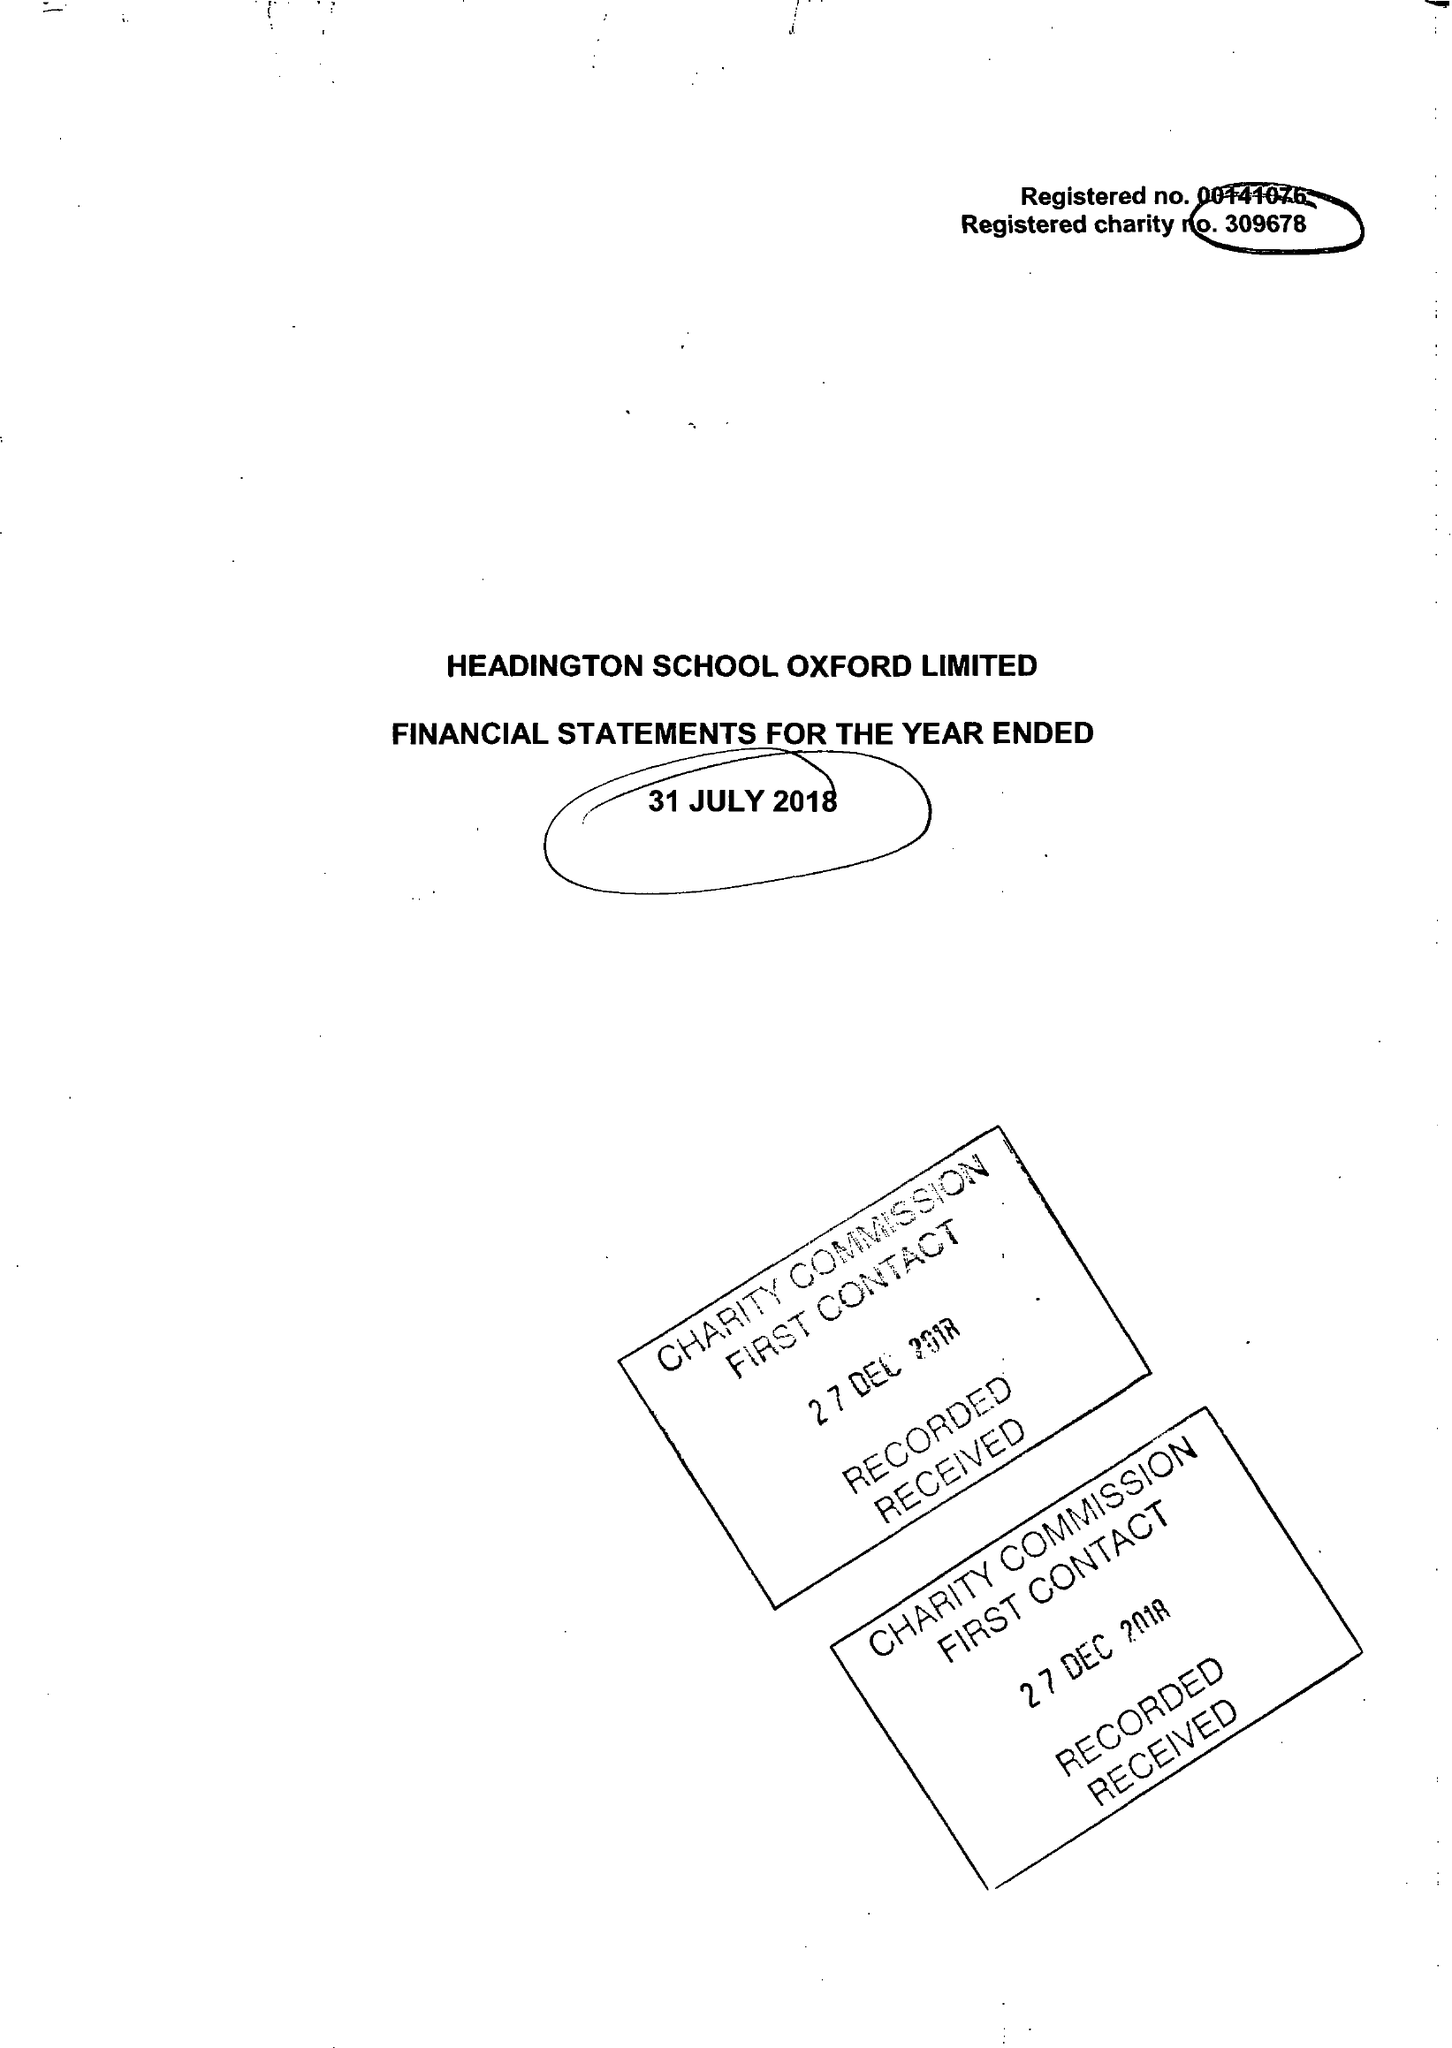What is the value for the report_date?
Answer the question using a single word or phrase. 2018-07-31 